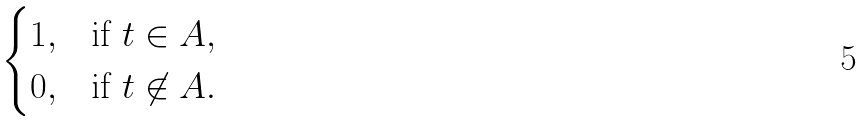Convert formula to latex. <formula><loc_0><loc_0><loc_500><loc_500>\begin{cases} 1 , & \text {if $t \in A$} , \\ 0 , & \text {if $t \not\in A$} . \end{cases}</formula> 